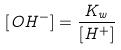<formula> <loc_0><loc_0><loc_500><loc_500>[ O H ^ { - } ] = \frac { K _ { w } } { [ H ^ { + } ] }</formula> 